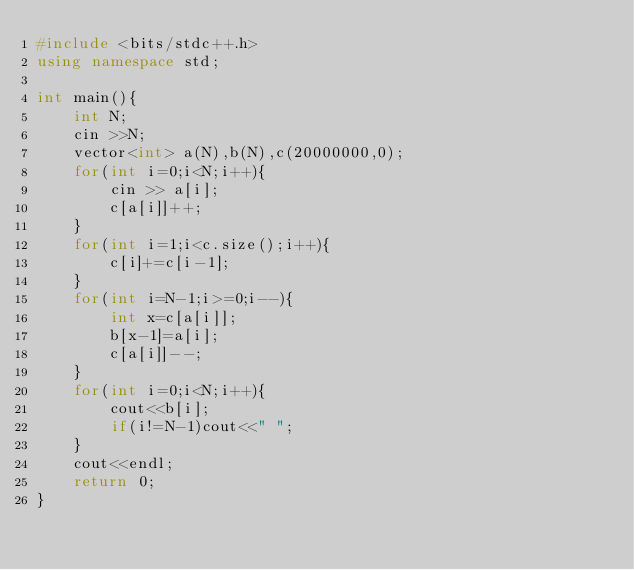Convert code to text. <code><loc_0><loc_0><loc_500><loc_500><_C++_>#include <bits/stdc++.h>
using namespace std;

int main(){
    int N;
    cin >>N;
    vector<int> a(N),b(N),c(20000000,0);
    for(int i=0;i<N;i++){
        cin >> a[i];
        c[a[i]]++;
    }
    for(int i=1;i<c.size();i++){
        c[i]+=c[i-1];
    }
    for(int i=N-1;i>=0;i--){
        int x=c[a[i]];
        b[x-1]=a[i];
        c[a[i]]--;
    }
    for(int i=0;i<N;i++){
        cout<<b[i];
        if(i!=N-1)cout<<" ";
    }
    cout<<endl;
    return 0;
}
</code> 